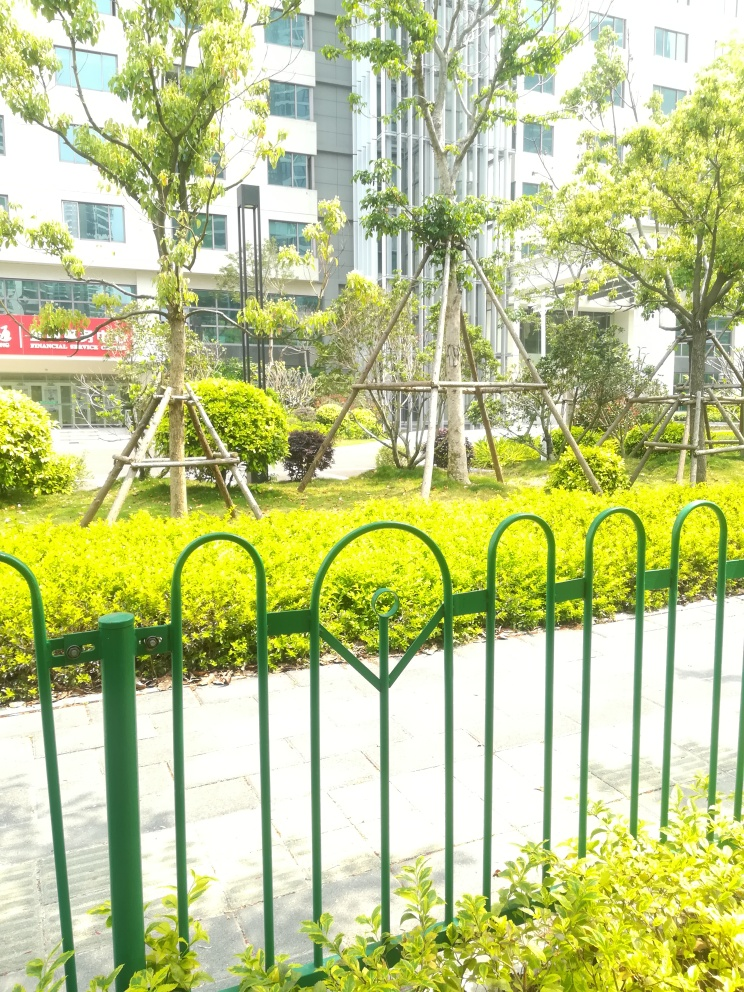Regarding the building in the background, what can we infer about its use and the environment it's situated in? The building in the background has a modern architectural style, with large windows suggesting it might be designed for commercial use, such as an office or an educational institution. Its proximity to the well-manicured garden indicates that it is likely situated in a well-planned urban area that values green spaces for relaxation or aesthetic purposes. The presence of what appears to be commercial signage on the lower part of the building supports the notion of business use. 